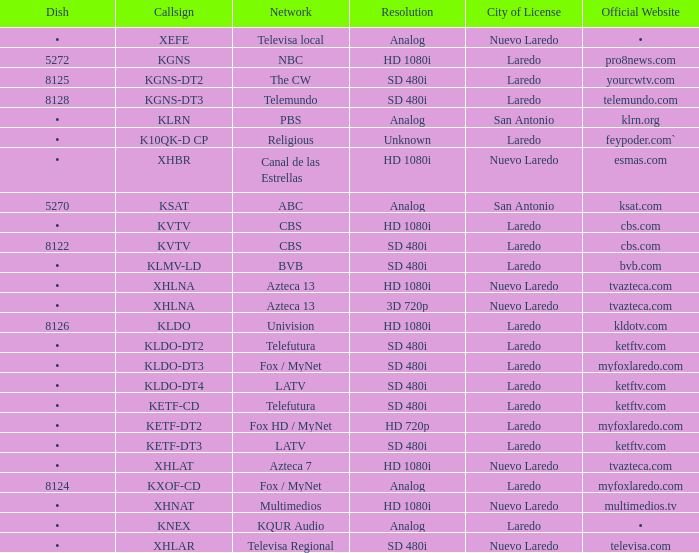In which city is the licensed sd 480i resolution and telemundo.com's official website located? Laredo. Write the full table. {'header': ['Dish', 'Callsign', 'Network', 'Resolution', 'City of License', 'Official Website'], 'rows': [['•', 'XEFE', 'Televisa local', 'Analog', 'Nuevo Laredo', '•'], ['5272', 'KGNS', 'NBC', 'HD 1080i', 'Laredo', 'pro8news.com'], ['8125', 'KGNS-DT2', 'The CW', 'SD 480i', 'Laredo', 'yourcwtv.com'], ['8128', 'KGNS-DT3', 'Telemundo', 'SD 480i', 'Laredo', 'telemundo.com'], ['•', 'KLRN', 'PBS', 'Analog', 'San Antonio', 'klrn.org'], ['•', 'K10QK-D CP', 'Religious', 'Unknown', 'Laredo', 'feypoder.com`'], ['•', 'XHBR', 'Canal de las Estrellas', 'HD 1080i', 'Nuevo Laredo', 'esmas.com'], ['5270', 'KSAT', 'ABC', 'Analog', 'San Antonio', 'ksat.com'], ['•', 'KVTV', 'CBS', 'HD 1080i', 'Laredo', 'cbs.com'], ['8122', 'KVTV', 'CBS', 'SD 480i', 'Laredo', 'cbs.com'], ['•', 'KLMV-LD', 'BVB', 'SD 480i', 'Laredo', 'bvb.com'], ['•', 'XHLNA', 'Azteca 13', 'HD 1080i', 'Nuevo Laredo', 'tvazteca.com'], ['•', 'XHLNA', 'Azteca 13', '3D 720p', 'Nuevo Laredo', 'tvazteca.com'], ['8126', 'KLDO', 'Univision', 'HD 1080i', 'Laredo', 'kldotv.com'], ['•', 'KLDO-DT2', 'Telefutura', 'SD 480i', 'Laredo', 'ketftv.com'], ['•', 'KLDO-DT3', 'Fox / MyNet', 'SD 480i', 'Laredo', 'myfoxlaredo.com'], ['•', 'KLDO-DT4', 'LATV', 'SD 480i', 'Laredo', 'ketftv.com'], ['•', 'KETF-CD', 'Telefutura', 'SD 480i', 'Laredo', 'ketftv.com'], ['•', 'KETF-DT2', 'Fox HD / MyNet', 'HD 720p', 'Laredo', 'myfoxlaredo.com'], ['•', 'KETF-DT3', 'LATV', 'SD 480i', 'Laredo', 'ketftv.com'], ['•', 'XHLAT', 'Azteca 7', 'HD 1080i', 'Nuevo Laredo', 'tvazteca.com'], ['8124', 'KXOF-CD', 'Fox / MyNet', 'Analog', 'Laredo', 'myfoxlaredo.com'], ['•', 'XHNAT', 'Multimedios', 'HD 1080i', 'Nuevo Laredo', 'multimedios.tv'], ['•', 'KNEX', 'KQUR Audio', 'Analog', 'Laredo', '•'], ['•', 'XHLAR', 'Televisa Regional', 'SD 480i', 'Nuevo Laredo', 'televisa.com']]} 